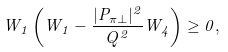<formula> <loc_0><loc_0><loc_500><loc_500>W _ { 1 } \left ( W _ { 1 } - \frac { | { P } _ { \pi \perp } | ^ { 2 } } { Q ^ { 2 } } W _ { 4 } \right ) \geq 0 ,</formula> 